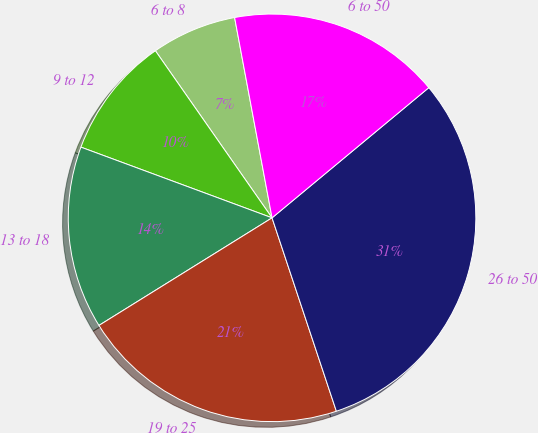Convert chart. <chart><loc_0><loc_0><loc_500><loc_500><pie_chart><fcel>6 to 8<fcel>9 to 12<fcel>13 to 18<fcel>19 to 25<fcel>26 to 50<fcel>6 to 50<nl><fcel>6.76%<fcel>9.66%<fcel>14.49%<fcel>21.26%<fcel>30.92%<fcel>16.91%<nl></chart> 